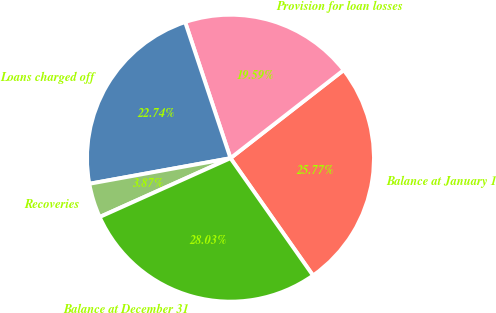<chart> <loc_0><loc_0><loc_500><loc_500><pie_chart><fcel>Balance at January 1<fcel>Provision for loan losses<fcel>Loans charged off<fcel>Recoveries<fcel>Balance at December 31<nl><fcel>25.77%<fcel>19.59%<fcel>22.74%<fcel>3.87%<fcel>28.03%<nl></chart> 